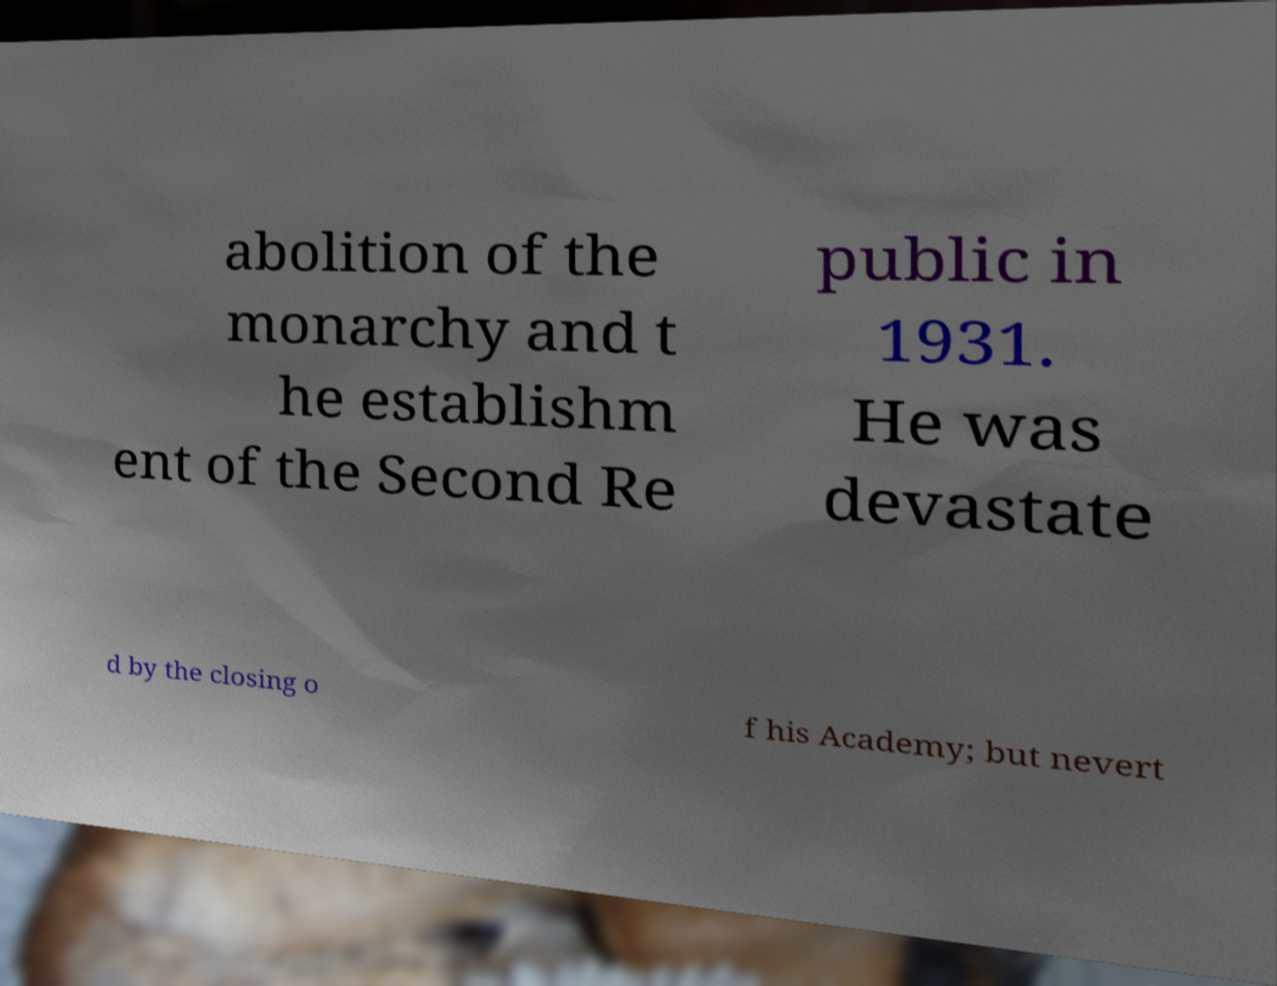Please identify and transcribe the text found in this image. abolition of the monarchy and t he establishm ent of the Second Re public in 1931. He was devastate d by the closing o f his Academy; but nevert 